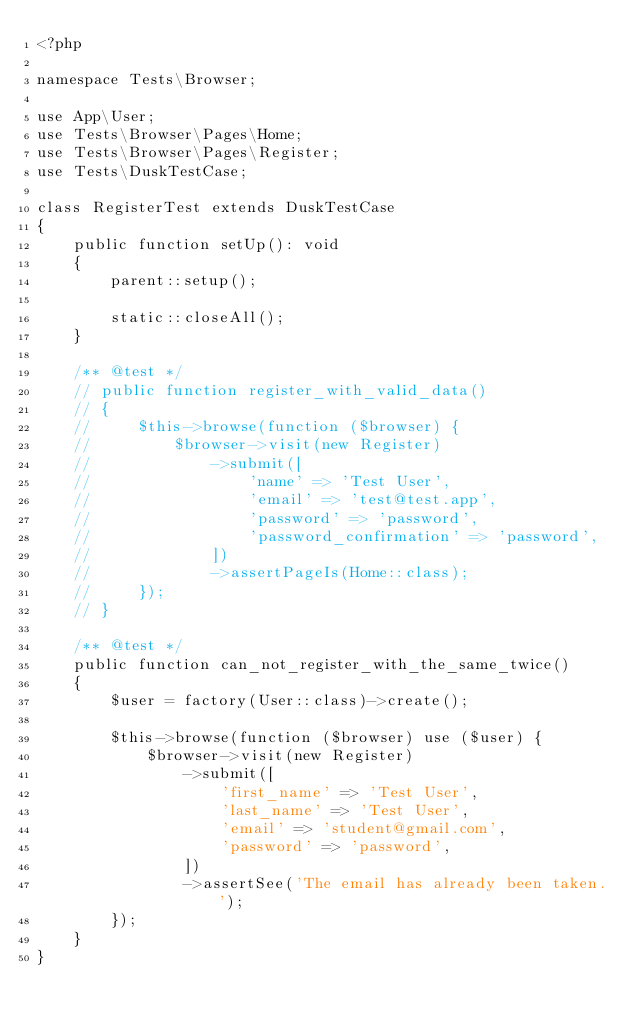Convert code to text. <code><loc_0><loc_0><loc_500><loc_500><_PHP_><?php

namespace Tests\Browser;

use App\User;
use Tests\Browser\Pages\Home;
use Tests\Browser\Pages\Register;
use Tests\DuskTestCase;

class RegisterTest extends DuskTestCase
{
    public function setUp(): void
    {
        parent::setup();

        static::closeAll();
    }

    /** @test */
    // public function register_with_valid_data()
    // {
    //     $this->browse(function ($browser) {
    //         $browser->visit(new Register)
    //             ->submit([
    //                 'name' => 'Test User',
    //                 'email' => 'test@test.app',
    //                 'password' => 'password',
    //                 'password_confirmation' => 'password',
    //             ])
    //             ->assertPageIs(Home::class);
    //     });
    // }

    /** @test */
    public function can_not_register_with_the_same_twice()
    {
        $user = factory(User::class)->create();

        $this->browse(function ($browser) use ($user) {
            $browser->visit(new Register)
                ->submit([
                    'first_name' => 'Test User',
                    'last_name' => 'Test User',
                    'email' => 'student@gmail.com',
                    'password' => 'password',
                ])
                ->assertSee('The email has already been taken.');
        });
    }
}
</code> 